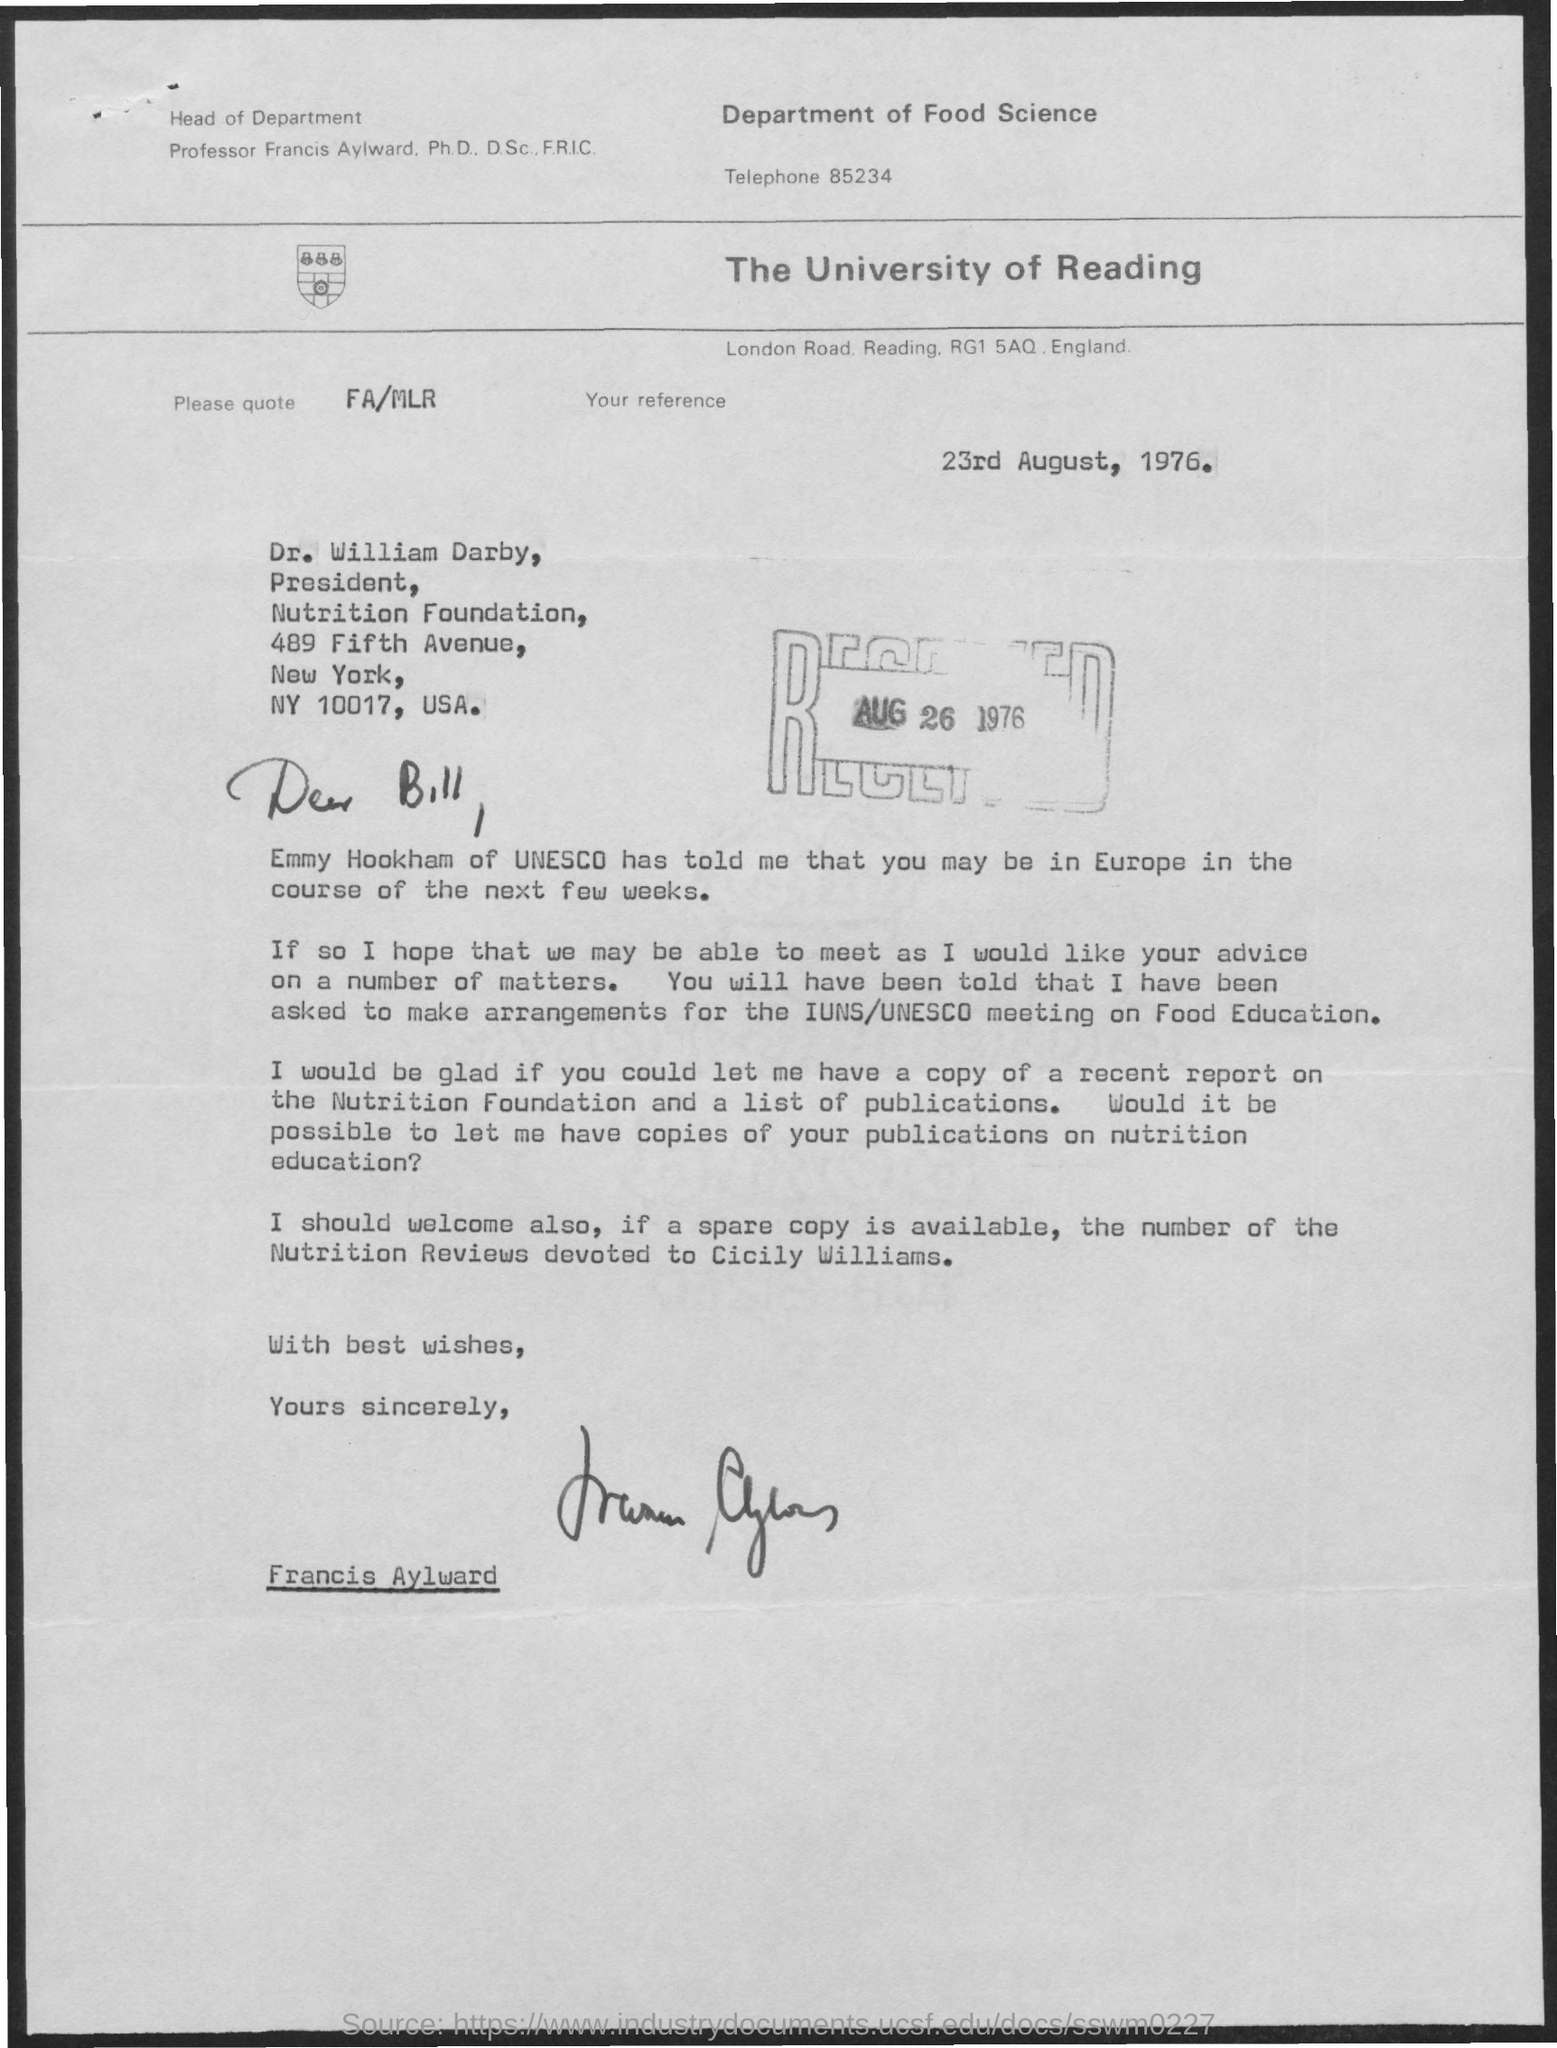Who is head of department ?
Make the answer very short. Francis Aylward. Which department is mentioned in the document ?
Keep it short and to the point. Department of Food Science. Who wrote the letter ?
Provide a short and direct response. Francis Aylward. 